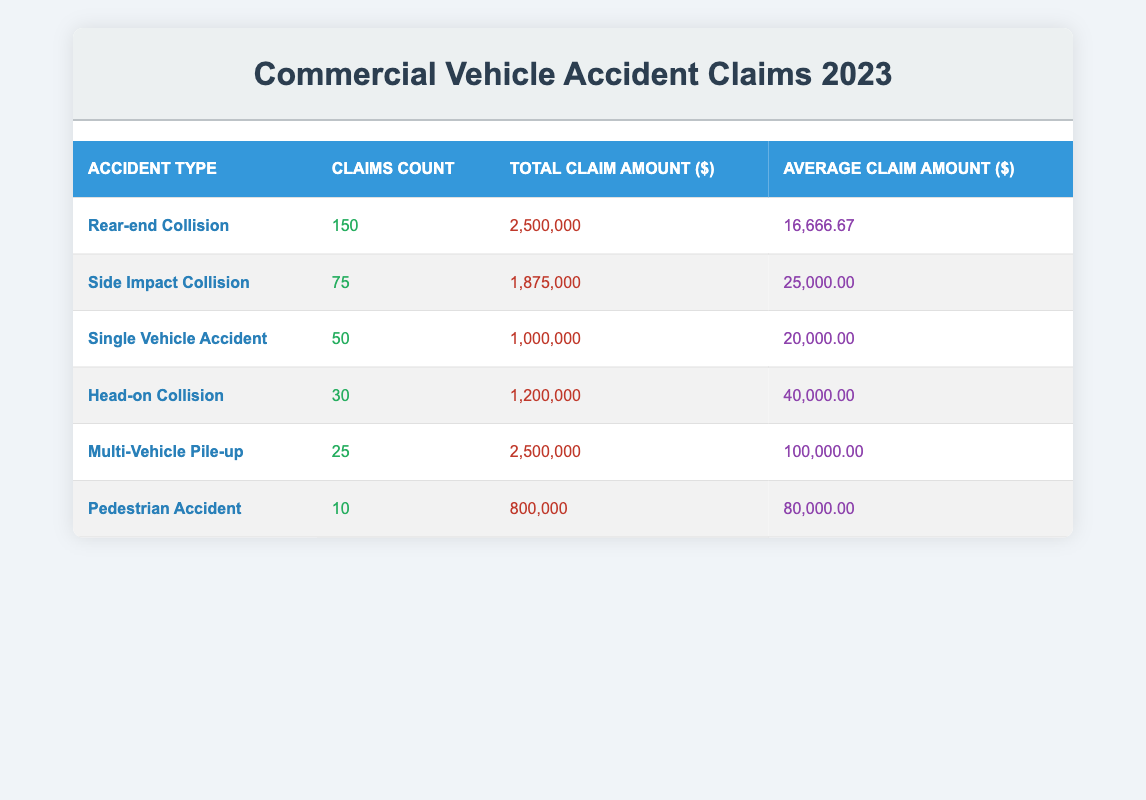What is the total claim amount for Rear-end Collision? The table lists the total claim amount for each accident type. For Rear-end Collision, it states the total claim amount is 2,500,000.
Answer: 2,500,000 How many claims were processed for Side Impact Collision? The table shows the claims count for Side Impact Collision, which is listed as 75.
Answer: 75 Which accident type has the highest average claim amount? To find the highest average claim amount, we compare the average amounts: Rear-end Collision (16,666.67), Side Impact Collision (25,000.00), Single Vehicle Accident (20,000.00), Head-on Collision (40,000.00), Multi-Vehicle Pile-up (100,000.00), and Pedestrian Accident (80,000.00). The highest is Multi-Vehicle Pile-up at 100,000.00.
Answer: Multi-Vehicle Pile-up Is the total claim amount for Pedestrian Accident greater than that for Single Vehicle Accident? The total claim amount for Pedestrian Accident is 800,000 and for Single Vehicle Accident is 1,000,000. Since 800,000 is less than 1,000,000, the answer is no.
Answer: No What is the average claim amount for Head-on Collision? The average claim amount for Head-on Collision is directly stated in the table as 40,000.00.
Answer: 40,000.00 How many more claims were processed for Rear-end Collision compared to Pedestrian Accident? From the table, claims for Rear-end Collision are 150 and for Pedestrian Accident are 10. To find the difference: 150 - 10 = 140.
Answer: 140 What is the total claim amount for all accident types combined? We need to sum the total claim amounts for each accident type: 2,500,000 + 1,875,000 + 1,000,000 + 1,200,000 + 2,500,000 + 800,000 = 10,875,000.
Answer: 10,875,000 Is the average claim amount for Multi-Vehicle Pile-up greater than the average claim amount for all other accident types? The average for Multi-Vehicle Pile-up is 100,000.00. The averages for others are: Rear-end Collision (16,666.67), Side Impact Collision (25,000.00), Single Vehicle Accident (20,000.00), Head-on Collision (40,000.00), Pedestrian Accident (80,000.00). Comparing these, 100,000.00 is greater than all of them.
Answer: Yes How many claims were processed in total across all accident types? The claims count for each type is: Rear-end Collision (150), Side Impact Collision (75), Single Vehicle Accident (50), Head-on Collision (30), Multi-Vehicle Pile-up (25), and Pedestrian Accident (10). Adding these gives: 150 + 75 + 50 + 30 + 25 + 10 = 340.
Answer: 340 